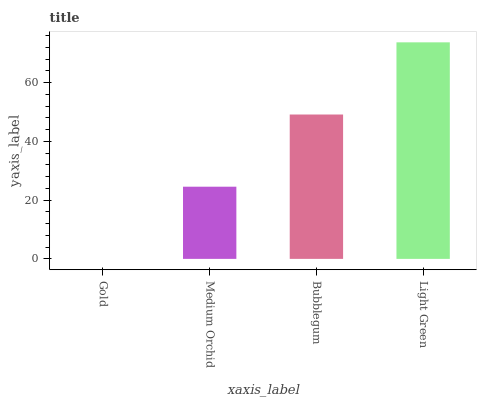Is Gold the minimum?
Answer yes or no. Yes. Is Light Green the maximum?
Answer yes or no. Yes. Is Medium Orchid the minimum?
Answer yes or no. No. Is Medium Orchid the maximum?
Answer yes or no. No. Is Medium Orchid greater than Gold?
Answer yes or no. Yes. Is Gold less than Medium Orchid?
Answer yes or no. Yes. Is Gold greater than Medium Orchid?
Answer yes or no. No. Is Medium Orchid less than Gold?
Answer yes or no. No. Is Bubblegum the high median?
Answer yes or no. Yes. Is Medium Orchid the low median?
Answer yes or no. Yes. Is Light Green the high median?
Answer yes or no. No. Is Light Green the low median?
Answer yes or no. No. 